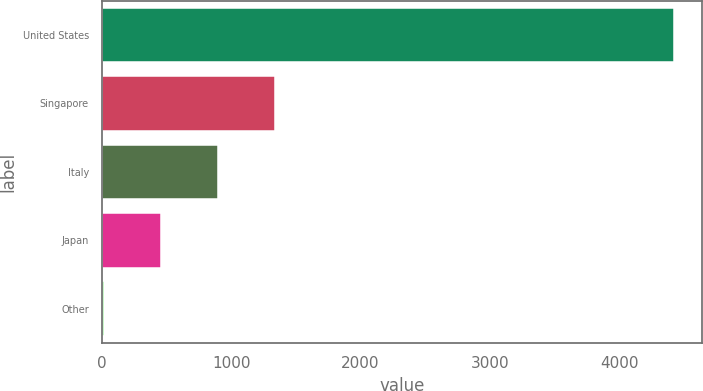<chart> <loc_0><loc_0><loc_500><loc_500><bar_chart><fcel>United States<fcel>Singapore<fcel>Italy<fcel>Japan<fcel>Other<nl><fcel>4422<fcel>1335<fcel>894<fcel>453<fcel>12<nl></chart> 